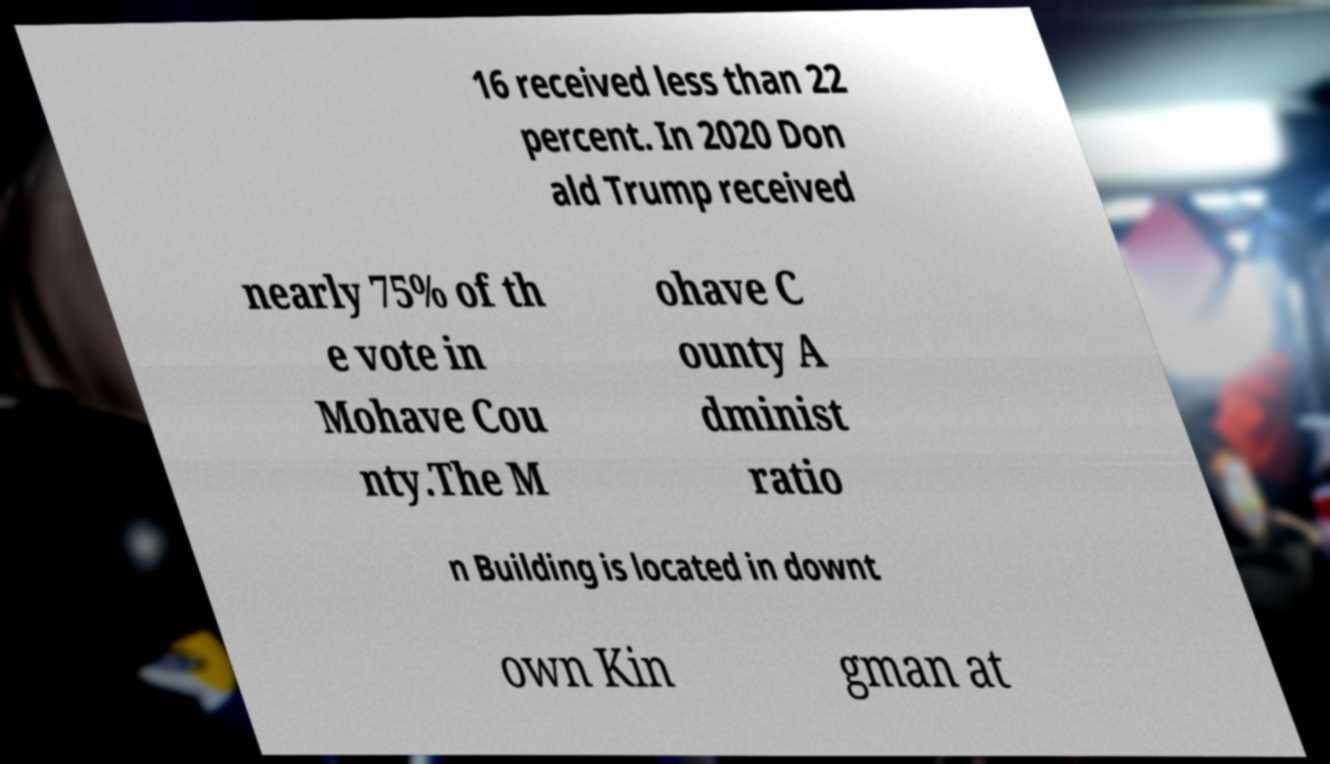There's text embedded in this image that I need extracted. Can you transcribe it verbatim? 16 received less than 22 percent. In 2020 Don ald Trump received nearly 75% of th e vote in Mohave Cou nty.The M ohave C ounty A dminist ratio n Building is located in downt own Kin gman at 